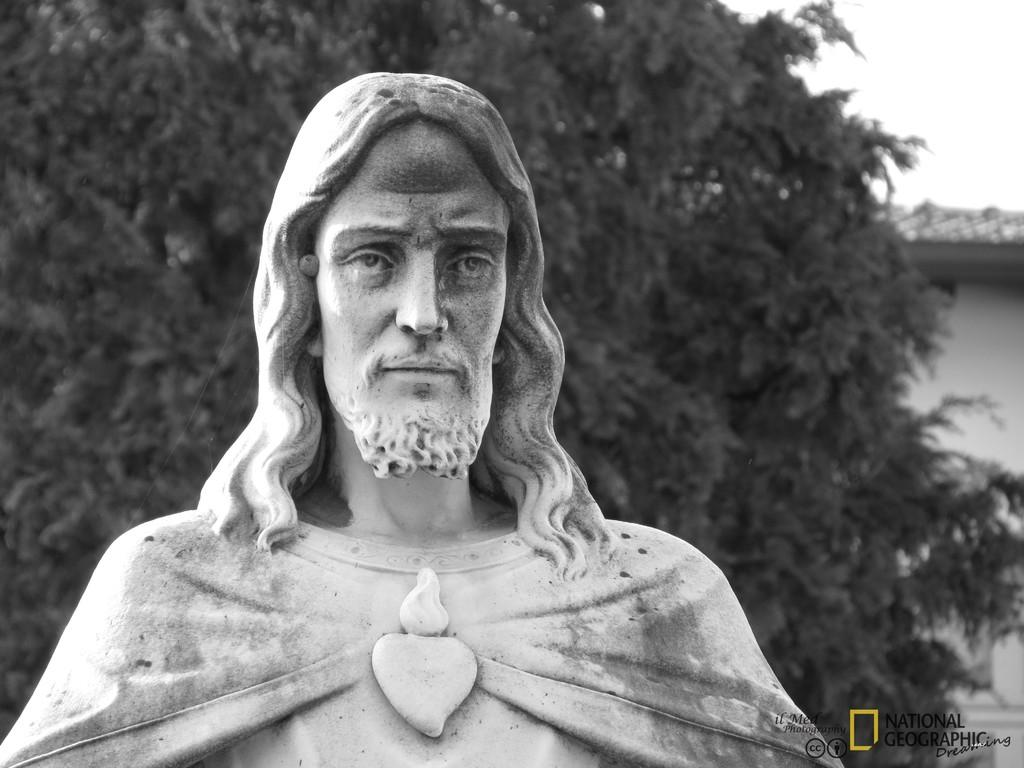What is the main subject of the image? The main subject of the image is a sculpture made up of rock. What can be seen in the background of the image? There is a tree and a house in the background of the image. What is visible at the top of the image? The sky is visible at the top of the image. What type of insurance policy is being discussed in the image? There is no discussion of insurance policies in the image; it features a rock sculpture, a tree, a house, and the sky. 